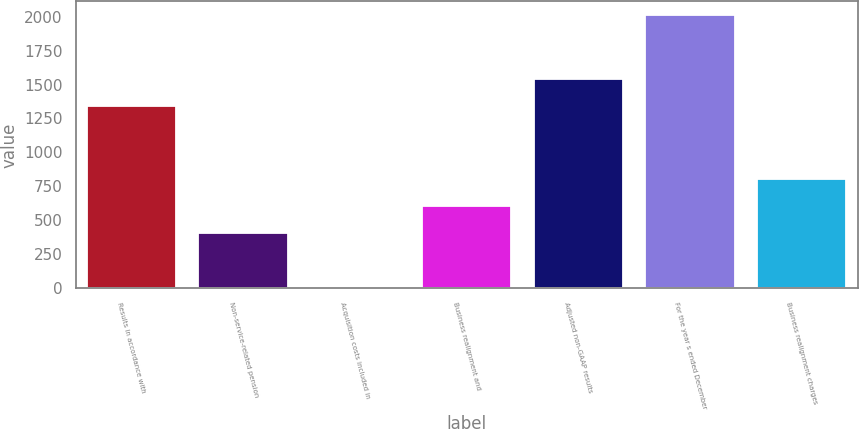Convert chart. <chart><loc_0><loc_0><loc_500><loc_500><bar_chart><fcel>Results in accordance with<fcel>Non-service-related pension<fcel>Acquisition costs included in<fcel>Business realignment and<fcel>Adjusted non-GAAP results<fcel>For the year s ended December<fcel>Business realignment charges<nl><fcel>1339.7<fcel>405.24<fcel>3.8<fcel>605.96<fcel>1540.42<fcel>2011<fcel>806.68<nl></chart> 